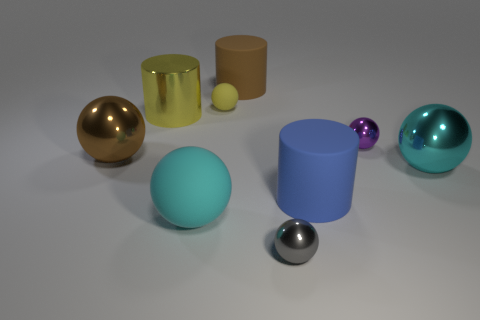Are there any large blue matte things that have the same shape as the small yellow rubber thing?
Provide a succinct answer. No. Are there fewer purple matte cylinders than tiny gray things?
Offer a terse response. Yes. Is the brown rubber object the same shape as the large brown metallic thing?
Your answer should be very brief. No. What number of objects are large cyan spheres or big brown objects that are behind the small yellow thing?
Give a very brief answer. 3. How many tiny blue matte spheres are there?
Make the answer very short. 0. Are there any yellow cubes of the same size as the gray sphere?
Your answer should be very brief. No. Is the number of large cyan spheres to the right of the small yellow rubber thing less than the number of tiny gray objects?
Offer a very short reply. No. Does the gray shiny ball have the same size as the purple shiny thing?
Offer a very short reply. Yes. What size is the purple object that is made of the same material as the small gray object?
Offer a terse response. Small. What number of balls are the same color as the big metallic cylinder?
Provide a short and direct response. 1. 